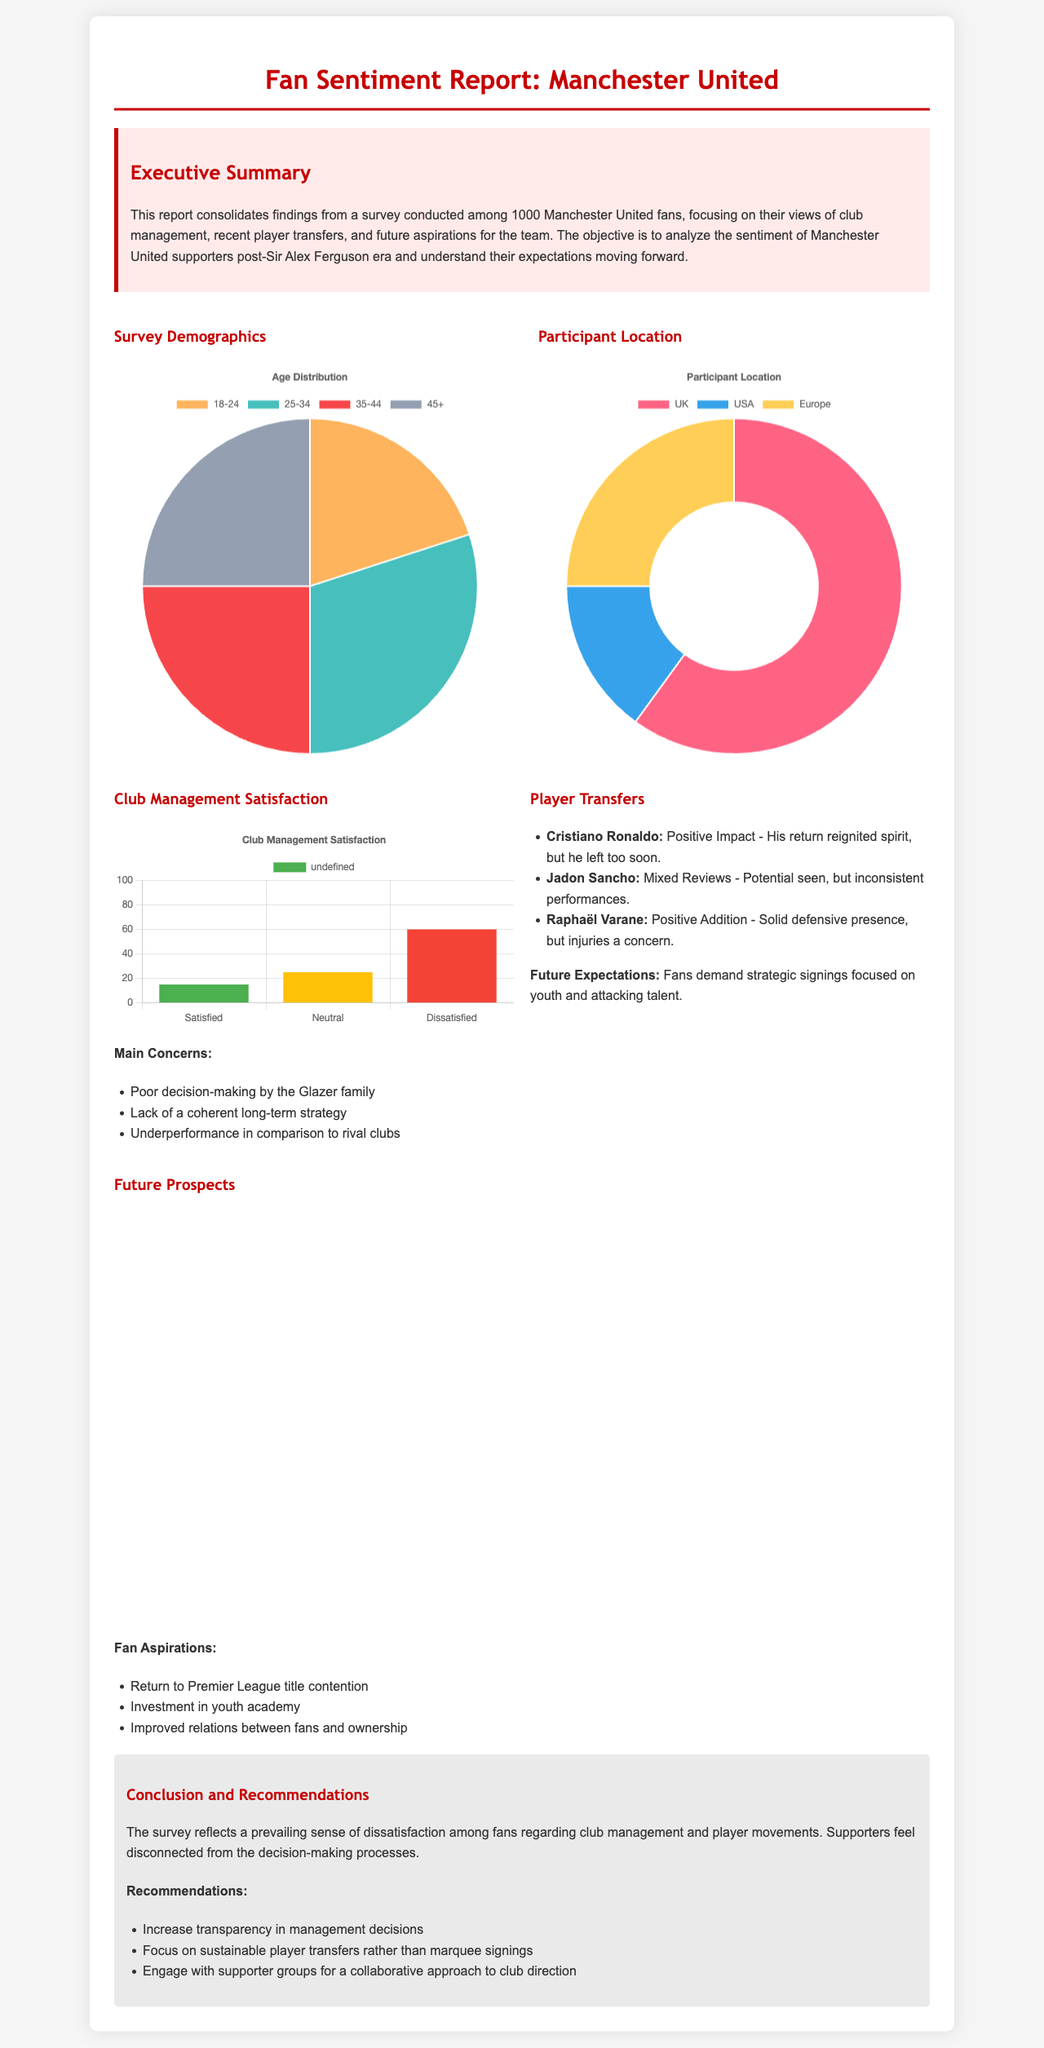What was the sample size of the survey? The report states that the survey was conducted among 1000 Manchester United fans.
Answer: 1000 What is the main concern regarding club management? The report lists the poor decision-making by the Glazer family as a key concern among fans.
Answer: Poor decision-making by the Glazer family How do fans feel about Cristiano Ronaldo's return? The report indicates that fans viewed Cristiano Ronaldo's return as a positive impact but noted that he left too soon.
Answer: Positive Impact What percentage of participants are aged 25-34? The age demographics chart indicates that 30% of participants are aged 25-34.
Answer: 30% What is the sentiment towards future prospects? The optimism chart indicates that the majority of fans feel pessimistic about future prospects for the club.
Answer: Pessimistic Which recommendation suggests improving management transparency? The recommendation to increase transparency in management decisions aims to address fans' concerns.
Answer: Increase transparency in management decisions What is the distribution of participants from the UK? According to the participant location chart, 60% of the surveyed fans are from the UK.
Answer: 60% What do fans demand regarding player signings? The report mentions that fans demand strategic signings focused on youth and attacking talent.
Answer: Strategic signings focused on youth and attacking talent 